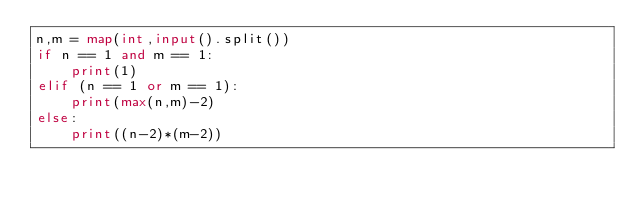<code> <loc_0><loc_0><loc_500><loc_500><_Python_>n,m = map(int,input().split())
if n == 1 and m == 1:
    print(1)
elif (n == 1 or m == 1):
    print(max(n,m)-2)
else:
    print((n-2)*(m-2))</code> 